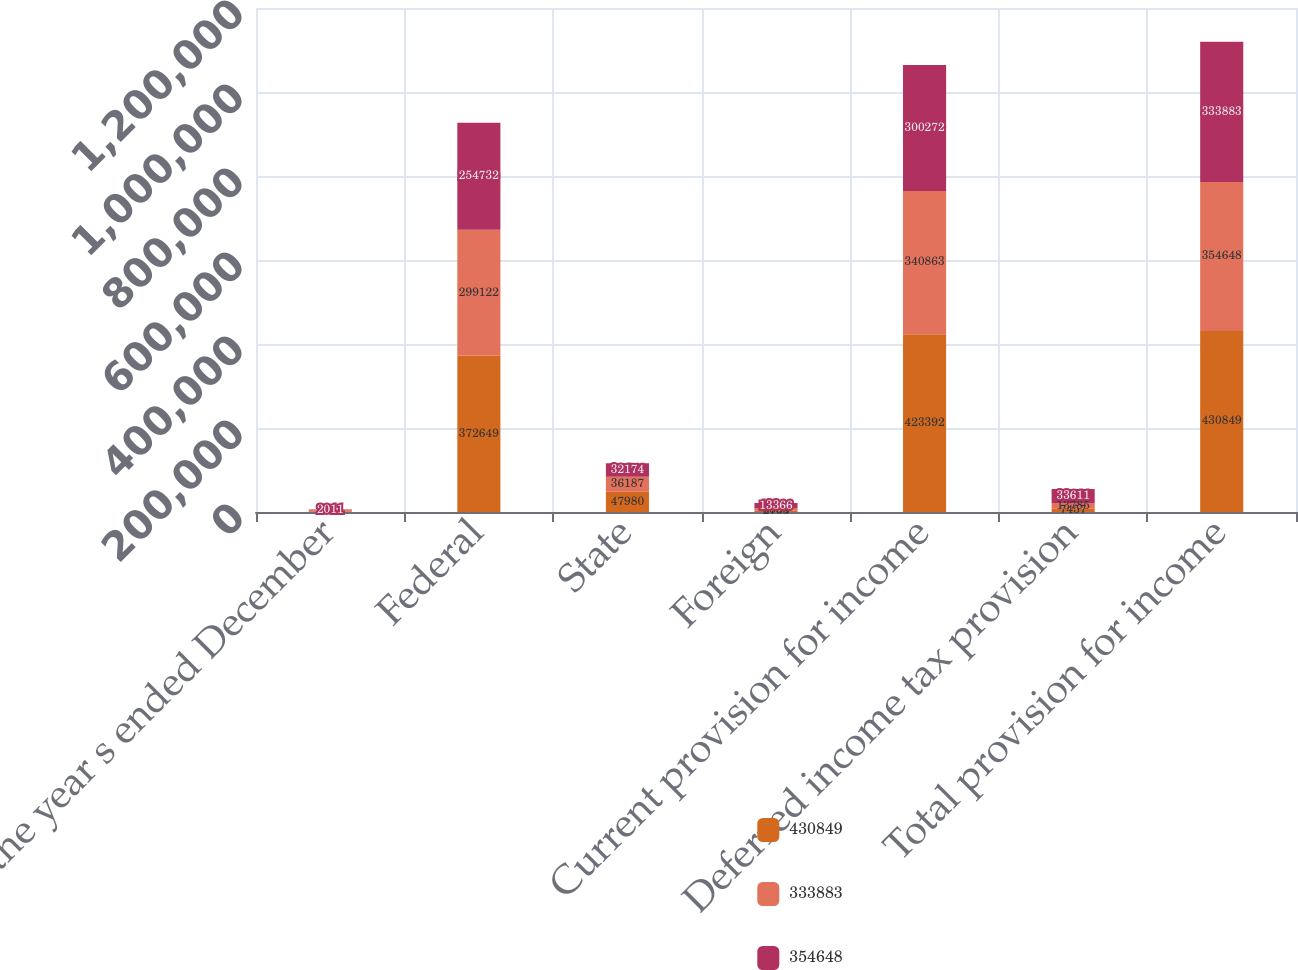<chart> <loc_0><loc_0><loc_500><loc_500><stacked_bar_chart><ecel><fcel>For the year s ended December<fcel>Federal<fcel>State<fcel>Foreign<fcel>Current provision for income<fcel>Deferred income tax provision<fcel>Total provision for income<nl><fcel>430849<fcel>2013<fcel>372649<fcel>47980<fcel>2763<fcel>423392<fcel>7457<fcel>430849<nl><fcel>333883<fcel>2012<fcel>299122<fcel>36187<fcel>5554<fcel>340863<fcel>13785<fcel>354648<nl><fcel>354648<fcel>2011<fcel>254732<fcel>32174<fcel>13366<fcel>300272<fcel>33611<fcel>333883<nl></chart> 